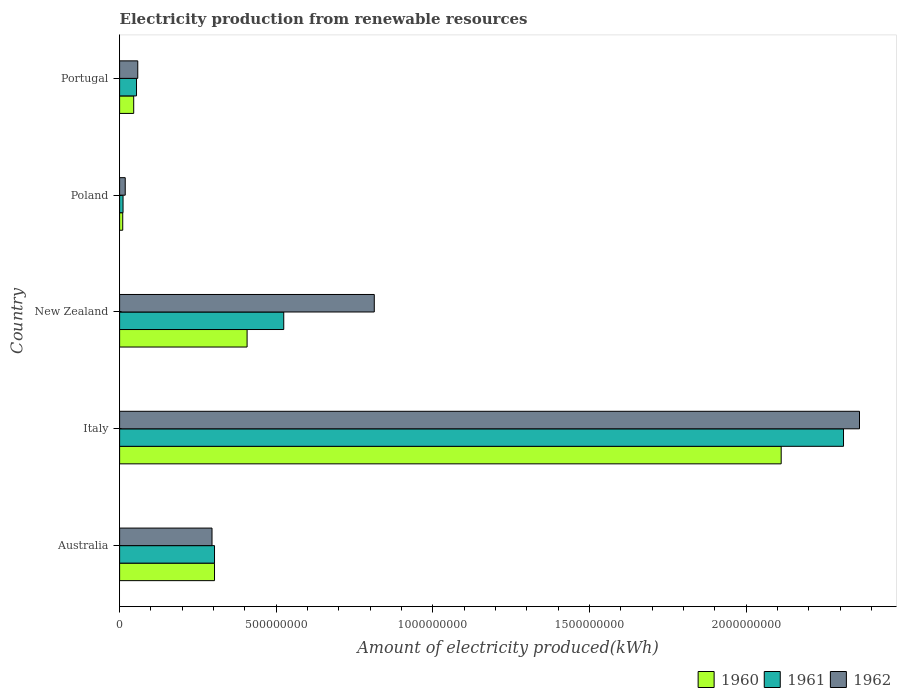How many different coloured bars are there?
Your answer should be very brief. 3. Are the number of bars on each tick of the Y-axis equal?
Provide a succinct answer. Yes. How many bars are there on the 1st tick from the bottom?
Give a very brief answer. 3. What is the label of the 5th group of bars from the top?
Offer a very short reply. Australia. What is the amount of electricity produced in 1960 in Italy?
Offer a very short reply. 2.11e+09. Across all countries, what is the maximum amount of electricity produced in 1960?
Ensure brevity in your answer.  2.11e+09. Across all countries, what is the minimum amount of electricity produced in 1961?
Offer a very short reply. 1.10e+07. In which country was the amount of electricity produced in 1962 maximum?
Offer a terse response. Italy. What is the total amount of electricity produced in 1961 in the graph?
Make the answer very short. 3.20e+09. What is the difference between the amount of electricity produced in 1960 in Poland and that in Portugal?
Provide a short and direct response. -3.50e+07. What is the difference between the amount of electricity produced in 1960 in Poland and the amount of electricity produced in 1961 in Italy?
Your response must be concise. -2.30e+09. What is the average amount of electricity produced in 1962 per country?
Provide a succinct answer. 7.09e+08. What is the difference between the amount of electricity produced in 1960 and amount of electricity produced in 1961 in Poland?
Offer a very short reply. -1.00e+06. What is the ratio of the amount of electricity produced in 1962 in Italy to that in New Zealand?
Make the answer very short. 2.91. What is the difference between the highest and the second highest amount of electricity produced in 1960?
Keep it short and to the point. 1.70e+09. What is the difference between the highest and the lowest amount of electricity produced in 1962?
Provide a succinct answer. 2.34e+09. In how many countries, is the amount of electricity produced in 1961 greater than the average amount of electricity produced in 1961 taken over all countries?
Offer a terse response. 1. Is the sum of the amount of electricity produced in 1961 in Australia and New Zealand greater than the maximum amount of electricity produced in 1962 across all countries?
Provide a succinct answer. No. What does the 1st bar from the bottom in New Zealand represents?
Ensure brevity in your answer.  1960. How many countries are there in the graph?
Offer a terse response. 5. Are the values on the major ticks of X-axis written in scientific E-notation?
Your response must be concise. No. Does the graph contain grids?
Your answer should be very brief. No. How many legend labels are there?
Your answer should be very brief. 3. How are the legend labels stacked?
Provide a succinct answer. Horizontal. What is the title of the graph?
Give a very brief answer. Electricity production from renewable resources. Does "2002" appear as one of the legend labels in the graph?
Your answer should be compact. No. What is the label or title of the X-axis?
Keep it short and to the point. Amount of electricity produced(kWh). What is the label or title of the Y-axis?
Your answer should be compact. Country. What is the Amount of electricity produced(kWh) in 1960 in Australia?
Keep it short and to the point. 3.03e+08. What is the Amount of electricity produced(kWh) of 1961 in Australia?
Your response must be concise. 3.03e+08. What is the Amount of electricity produced(kWh) in 1962 in Australia?
Your response must be concise. 2.95e+08. What is the Amount of electricity produced(kWh) of 1960 in Italy?
Give a very brief answer. 2.11e+09. What is the Amount of electricity produced(kWh) in 1961 in Italy?
Your answer should be compact. 2.31e+09. What is the Amount of electricity produced(kWh) of 1962 in Italy?
Your response must be concise. 2.36e+09. What is the Amount of electricity produced(kWh) in 1960 in New Zealand?
Keep it short and to the point. 4.07e+08. What is the Amount of electricity produced(kWh) in 1961 in New Zealand?
Your response must be concise. 5.24e+08. What is the Amount of electricity produced(kWh) in 1962 in New Zealand?
Ensure brevity in your answer.  8.13e+08. What is the Amount of electricity produced(kWh) of 1961 in Poland?
Provide a succinct answer. 1.10e+07. What is the Amount of electricity produced(kWh) in 1962 in Poland?
Your answer should be compact. 1.80e+07. What is the Amount of electricity produced(kWh) in 1960 in Portugal?
Your answer should be very brief. 4.50e+07. What is the Amount of electricity produced(kWh) of 1961 in Portugal?
Provide a succinct answer. 5.40e+07. What is the Amount of electricity produced(kWh) of 1962 in Portugal?
Provide a short and direct response. 5.80e+07. Across all countries, what is the maximum Amount of electricity produced(kWh) in 1960?
Provide a short and direct response. 2.11e+09. Across all countries, what is the maximum Amount of electricity produced(kWh) in 1961?
Provide a succinct answer. 2.31e+09. Across all countries, what is the maximum Amount of electricity produced(kWh) of 1962?
Make the answer very short. 2.36e+09. Across all countries, what is the minimum Amount of electricity produced(kWh) of 1960?
Keep it short and to the point. 1.00e+07. Across all countries, what is the minimum Amount of electricity produced(kWh) of 1961?
Your answer should be very brief. 1.10e+07. Across all countries, what is the minimum Amount of electricity produced(kWh) of 1962?
Make the answer very short. 1.80e+07. What is the total Amount of electricity produced(kWh) in 1960 in the graph?
Your response must be concise. 2.88e+09. What is the total Amount of electricity produced(kWh) in 1961 in the graph?
Provide a short and direct response. 3.20e+09. What is the total Amount of electricity produced(kWh) of 1962 in the graph?
Give a very brief answer. 3.55e+09. What is the difference between the Amount of electricity produced(kWh) of 1960 in Australia and that in Italy?
Offer a terse response. -1.81e+09. What is the difference between the Amount of electricity produced(kWh) of 1961 in Australia and that in Italy?
Give a very brief answer. -2.01e+09. What is the difference between the Amount of electricity produced(kWh) of 1962 in Australia and that in Italy?
Your response must be concise. -2.07e+09. What is the difference between the Amount of electricity produced(kWh) of 1960 in Australia and that in New Zealand?
Provide a succinct answer. -1.04e+08. What is the difference between the Amount of electricity produced(kWh) of 1961 in Australia and that in New Zealand?
Your answer should be very brief. -2.21e+08. What is the difference between the Amount of electricity produced(kWh) in 1962 in Australia and that in New Zealand?
Provide a succinct answer. -5.18e+08. What is the difference between the Amount of electricity produced(kWh) of 1960 in Australia and that in Poland?
Offer a very short reply. 2.93e+08. What is the difference between the Amount of electricity produced(kWh) in 1961 in Australia and that in Poland?
Your answer should be very brief. 2.92e+08. What is the difference between the Amount of electricity produced(kWh) of 1962 in Australia and that in Poland?
Give a very brief answer. 2.77e+08. What is the difference between the Amount of electricity produced(kWh) in 1960 in Australia and that in Portugal?
Offer a very short reply. 2.58e+08. What is the difference between the Amount of electricity produced(kWh) in 1961 in Australia and that in Portugal?
Offer a very short reply. 2.49e+08. What is the difference between the Amount of electricity produced(kWh) of 1962 in Australia and that in Portugal?
Offer a very short reply. 2.37e+08. What is the difference between the Amount of electricity produced(kWh) of 1960 in Italy and that in New Zealand?
Offer a terse response. 1.70e+09. What is the difference between the Amount of electricity produced(kWh) of 1961 in Italy and that in New Zealand?
Give a very brief answer. 1.79e+09. What is the difference between the Amount of electricity produced(kWh) of 1962 in Italy and that in New Zealand?
Your answer should be compact. 1.55e+09. What is the difference between the Amount of electricity produced(kWh) of 1960 in Italy and that in Poland?
Offer a terse response. 2.10e+09. What is the difference between the Amount of electricity produced(kWh) of 1961 in Italy and that in Poland?
Your response must be concise. 2.30e+09. What is the difference between the Amount of electricity produced(kWh) of 1962 in Italy and that in Poland?
Your response must be concise. 2.34e+09. What is the difference between the Amount of electricity produced(kWh) in 1960 in Italy and that in Portugal?
Give a very brief answer. 2.07e+09. What is the difference between the Amount of electricity produced(kWh) in 1961 in Italy and that in Portugal?
Your response must be concise. 2.26e+09. What is the difference between the Amount of electricity produced(kWh) of 1962 in Italy and that in Portugal?
Ensure brevity in your answer.  2.30e+09. What is the difference between the Amount of electricity produced(kWh) of 1960 in New Zealand and that in Poland?
Offer a very short reply. 3.97e+08. What is the difference between the Amount of electricity produced(kWh) of 1961 in New Zealand and that in Poland?
Your response must be concise. 5.13e+08. What is the difference between the Amount of electricity produced(kWh) of 1962 in New Zealand and that in Poland?
Your answer should be very brief. 7.95e+08. What is the difference between the Amount of electricity produced(kWh) of 1960 in New Zealand and that in Portugal?
Offer a terse response. 3.62e+08. What is the difference between the Amount of electricity produced(kWh) of 1961 in New Zealand and that in Portugal?
Offer a terse response. 4.70e+08. What is the difference between the Amount of electricity produced(kWh) in 1962 in New Zealand and that in Portugal?
Your answer should be compact. 7.55e+08. What is the difference between the Amount of electricity produced(kWh) of 1960 in Poland and that in Portugal?
Ensure brevity in your answer.  -3.50e+07. What is the difference between the Amount of electricity produced(kWh) in 1961 in Poland and that in Portugal?
Provide a short and direct response. -4.30e+07. What is the difference between the Amount of electricity produced(kWh) in 1962 in Poland and that in Portugal?
Offer a terse response. -4.00e+07. What is the difference between the Amount of electricity produced(kWh) of 1960 in Australia and the Amount of electricity produced(kWh) of 1961 in Italy?
Provide a short and direct response. -2.01e+09. What is the difference between the Amount of electricity produced(kWh) of 1960 in Australia and the Amount of electricity produced(kWh) of 1962 in Italy?
Keep it short and to the point. -2.06e+09. What is the difference between the Amount of electricity produced(kWh) in 1961 in Australia and the Amount of electricity produced(kWh) in 1962 in Italy?
Keep it short and to the point. -2.06e+09. What is the difference between the Amount of electricity produced(kWh) of 1960 in Australia and the Amount of electricity produced(kWh) of 1961 in New Zealand?
Provide a short and direct response. -2.21e+08. What is the difference between the Amount of electricity produced(kWh) of 1960 in Australia and the Amount of electricity produced(kWh) of 1962 in New Zealand?
Offer a very short reply. -5.10e+08. What is the difference between the Amount of electricity produced(kWh) in 1961 in Australia and the Amount of electricity produced(kWh) in 1962 in New Zealand?
Ensure brevity in your answer.  -5.10e+08. What is the difference between the Amount of electricity produced(kWh) of 1960 in Australia and the Amount of electricity produced(kWh) of 1961 in Poland?
Make the answer very short. 2.92e+08. What is the difference between the Amount of electricity produced(kWh) of 1960 in Australia and the Amount of electricity produced(kWh) of 1962 in Poland?
Your response must be concise. 2.85e+08. What is the difference between the Amount of electricity produced(kWh) of 1961 in Australia and the Amount of electricity produced(kWh) of 1962 in Poland?
Ensure brevity in your answer.  2.85e+08. What is the difference between the Amount of electricity produced(kWh) of 1960 in Australia and the Amount of electricity produced(kWh) of 1961 in Portugal?
Offer a terse response. 2.49e+08. What is the difference between the Amount of electricity produced(kWh) of 1960 in Australia and the Amount of electricity produced(kWh) of 1962 in Portugal?
Provide a succinct answer. 2.45e+08. What is the difference between the Amount of electricity produced(kWh) of 1961 in Australia and the Amount of electricity produced(kWh) of 1962 in Portugal?
Offer a terse response. 2.45e+08. What is the difference between the Amount of electricity produced(kWh) of 1960 in Italy and the Amount of electricity produced(kWh) of 1961 in New Zealand?
Provide a short and direct response. 1.59e+09. What is the difference between the Amount of electricity produced(kWh) in 1960 in Italy and the Amount of electricity produced(kWh) in 1962 in New Zealand?
Provide a succinct answer. 1.30e+09. What is the difference between the Amount of electricity produced(kWh) of 1961 in Italy and the Amount of electricity produced(kWh) of 1962 in New Zealand?
Your answer should be compact. 1.50e+09. What is the difference between the Amount of electricity produced(kWh) of 1960 in Italy and the Amount of electricity produced(kWh) of 1961 in Poland?
Give a very brief answer. 2.10e+09. What is the difference between the Amount of electricity produced(kWh) of 1960 in Italy and the Amount of electricity produced(kWh) of 1962 in Poland?
Your answer should be very brief. 2.09e+09. What is the difference between the Amount of electricity produced(kWh) of 1961 in Italy and the Amount of electricity produced(kWh) of 1962 in Poland?
Your response must be concise. 2.29e+09. What is the difference between the Amount of electricity produced(kWh) in 1960 in Italy and the Amount of electricity produced(kWh) in 1961 in Portugal?
Provide a short and direct response. 2.06e+09. What is the difference between the Amount of electricity produced(kWh) of 1960 in Italy and the Amount of electricity produced(kWh) of 1962 in Portugal?
Your answer should be compact. 2.05e+09. What is the difference between the Amount of electricity produced(kWh) in 1961 in Italy and the Amount of electricity produced(kWh) in 1962 in Portugal?
Offer a terse response. 2.25e+09. What is the difference between the Amount of electricity produced(kWh) in 1960 in New Zealand and the Amount of electricity produced(kWh) in 1961 in Poland?
Your answer should be compact. 3.96e+08. What is the difference between the Amount of electricity produced(kWh) of 1960 in New Zealand and the Amount of electricity produced(kWh) of 1962 in Poland?
Your response must be concise. 3.89e+08. What is the difference between the Amount of electricity produced(kWh) of 1961 in New Zealand and the Amount of electricity produced(kWh) of 1962 in Poland?
Make the answer very short. 5.06e+08. What is the difference between the Amount of electricity produced(kWh) of 1960 in New Zealand and the Amount of electricity produced(kWh) of 1961 in Portugal?
Make the answer very short. 3.53e+08. What is the difference between the Amount of electricity produced(kWh) in 1960 in New Zealand and the Amount of electricity produced(kWh) in 1962 in Portugal?
Offer a terse response. 3.49e+08. What is the difference between the Amount of electricity produced(kWh) in 1961 in New Zealand and the Amount of electricity produced(kWh) in 1962 in Portugal?
Provide a succinct answer. 4.66e+08. What is the difference between the Amount of electricity produced(kWh) in 1960 in Poland and the Amount of electricity produced(kWh) in 1961 in Portugal?
Give a very brief answer. -4.40e+07. What is the difference between the Amount of electricity produced(kWh) in 1960 in Poland and the Amount of electricity produced(kWh) in 1962 in Portugal?
Your answer should be very brief. -4.80e+07. What is the difference between the Amount of electricity produced(kWh) of 1961 in Poland and the Amount of electricity produced(kWh) of 1962 in Portugal?
Offer a terse response. -4.70e+07. What is the average Amount of electricity produced(kWh) in 1960 per country?
Provide a short and direct response. 5.75e+08. What is the average Amount of electricity produced(kWh) in 1961 per country?
Offer a terse response. 6.41e+08. What is the average Amount of electricity produced(kWh) in 1962 per country?
Keep it short and to the point. 7.09e+08. What is the difference between the Amount of electricity produced(kWh) in 1960 and Amount of electricity produced(kWh) in 1962 in Australia?
Your answer should be compact. 8.00e+06. What is the difference between the Amount of electricity produced(kWh) in 1960 and Amount of electricity produced(kWh) in 1961 in Italy?
Keep it short and to the point. -1.99e+08. What is the difference between the Amount of electricity produced(kWh) in 1960 and Amount of electricity produced(kWh) in 1962 in Italy?
Give a very brief answer. -2.50e+08. What is the difference between the Amount of electricity produced(kWh) of 1961 and Amount of electricity produced(kWh) of 1962 in Italy?
Offer a very short reply. -5.10e+07. What is the difference between the Amount of electricity produced(kWh) of 1960 and Amount of electricity produced(kWh) of 1961 in New Zealand?
Give a very brief answer. -1.17e+08. What is the difference between the Amount of electricity produced(kWh) of 1960 and Amount of electricity produced(kWh) of 1962 in New Zealand?
Offer a terse response. -4.06e+08. What is the difference between the Amount of electricity produced(kWh) in 1961 and Amount of electricity produced(kWh) in 1962 in New Zealand?
Give a very brief answer. -2.89e+08. What is the difference between the Amount of electricity produced(kWh) of 1960 and Amount of electricity produced(kWh) of 1961 in Poland?
Make the answer very short. -1.00e+06. What is the difference between the Amount of electricity produced(kWh) in 1960 and Amount of electricity produced(kWh) in 1962 in Poland?
Provide a succinct answer. -8.00e+06. What is the difference between the Amount of electricity produced(kWh) of 1961 and Amount of electricity produced(kWh) of 1962 in Poland?
Provide a short and direct response. -7.00e+06. What is the difference between the Amount of electricity produced(kWh) of 1960 and Amount of electricity produced(kWh) of 1961 in Portugal?
Make the answer very short. -9.00e+06. What is the difference between the Amount of electricity produced(kWh) of 1960 and Amount of electricity produced(kWh) of 1962 in Portugal?
Provide a succinct answer. -1.30e+07. What is the ratio of the Amount of electricity produced(kWh) in 1960 in Australia to that in Italy?
Make the answer very short. 0.14. What is the ratio of the Amount of electricity produced(kWh) in 1961 in Australia to that in Italy?
Give a very brief answer. 0.13. What is the ratio of the Amount of electricity produced(kWh) of 1962 in Australia to that in Italy?
Offer a terse response. 0.12. What is the ratio of the Amount of electricity produced(kWh) of 1960 in Australia to that in New Zealand?
Your answer should be compact. 0.74. What is the ratio of the Amount of electricity produced(kWh) in 1961 in Australia to that in New Zealand?
Your answer should be compact. 0.58. What is the ratio of the Amount of electricity produced(kWh) in 1962 in Australia to that in New Zealand?
Offer a terse response. 0.36. What is the ratio of the Amount of electricity produced(kWh) in 1960 in Australia to that in Poland?
Offer a terse response. 30.3. What is the ratio of the Amount of electricity produced(kWh) in 1961 in Australia to that in Poland?
Make the answer very short. 27.55. What is the ratio of the Amount of electricity produced(kWh) in 1962 in Australia to that in Poland?
Provide a short and direct response. 16.39. What is the ratio of the Amount of electricity produced(kWh) in 1960 in Australia to that in Portugal?
Ensure brevity in your answer.  6.73. What is the ratio of the Amount of electricity produced(kWh) of 1961 in Australia to that in Portugal?
Offer a terse response. 5.61. What is the ratio of the Amount of electricity produced(kWh) of 1962 in Australia to that in Portugal?
Your answer should be compact. 5.09. What is the ratio of the Amount of electricity produced(kWh) in 1960 in Italy to that in New Zealand?
Offer a very short reply. 5.19. What is the ratio of the Amount of electricity produced(kWh) of 1961 in Italy to that in New Zealand?
Keep it short and to the point. 4.41. What is the ratio of the Amount of electricity produced(kWh) in 1962 in Italy to that in New Zealand?
Your response must be concise. 2.91. What is the ratio of the Amount of electricity produced(kWh) in 1960 in Italy to that in Poland?
Keep it short and to the point. 211.2. What is the ratio of the Amount of electricity produced(kWh) of 1961 in Italy to that in Poland?
Your answer should be very brief. 210.09. What is the ratio of the Amount of electricity produced(kWh) in 1962 in Italy to that in Poland?
Your answer should be very brief. 131.22. What is the ratio of the Amount of electricity produced(kWh) in 1960 in Italy to that in Portugal?
Provide a short and direct response. 46.93. What is the ratio of the Amount of electricity produced(kWh) in 1961 in Italy to that in Portugal?
Provide a short and direct response. 42.8. What is the ratio of the Amount of electricity produced(kWh) of 1962 in Italy to that in Portugal?
Provide a short and direct response. 40.72. What is the ratio of the Amount of electricity produced(kWh) in 1960 in New Zealand to that in Poland?
Offer a terse response. 40.7. What is the ratio of the Amount of electricity produced(kWh) in 1961 in New Zealand to that in Poland?
Your answer should be compact. 47.64. What is the ratio of the Amount of electricity produced(kWh) in 1962 in New Zealand to that in Poland?
Keep it short and to the point. 45.17. What is the ratio of the Amount of electricity produced(kWh) of 1960 in New Zealand to that in Portugal?
Offer a very short reply. 9.04. What is the ratio of the Amount of electricity produced(kWh) in 1961 in New Zealand to that in Portugal?
Provide a short and direct response. 9.7. What is the ratio of the Amount of electricity produced(kWh) in 1962 in New Zealand to that in Portugal?
Your answer should be very brief. 14.02. What is the ratio of the Amount of electricity produced(kWh) in 1960 in Poland to that in Portugal?
Provide a short and direct response. 0.22. What is the ratio of the Amount of electricity produced(kWh) of 1961 in Poland to that in Portugal?
Provide a succinct answer. 0.2. What is the ratio of the Amount of electricity produced(kWh) in 1962 in Poland to that in Portugal?
Offer a terse response. 0.31. What is the difference between the highest and the second highest Amount of electricity produced(kWh) of 1960?
Provide a succinct answer. 1.70e+09. What is the difference between the highest and the second highest Amount of electricity produced(kWh) in 1961?
Provide a succinct answer. 1.79e+09. What is the difference between the highest and the second highest Amount of electricity produced(kWh) of 1962?
Give a very brief answer. 1.55e+09. What is the difference between the highest and the lowest Amount of electricity produced(kWh) in 1960?
Ensure brevity in your answer.  2.10e+09. What is the difference between the highest and the lowest Amount of electricity produced(kWh) in 1961?
Offer a very short reply. 2.30e+09. What is the difference between the highest and the lowest Amount of electricity produced(kWh) of 1962?
Provide a short and direct response. 2.34e+09. 